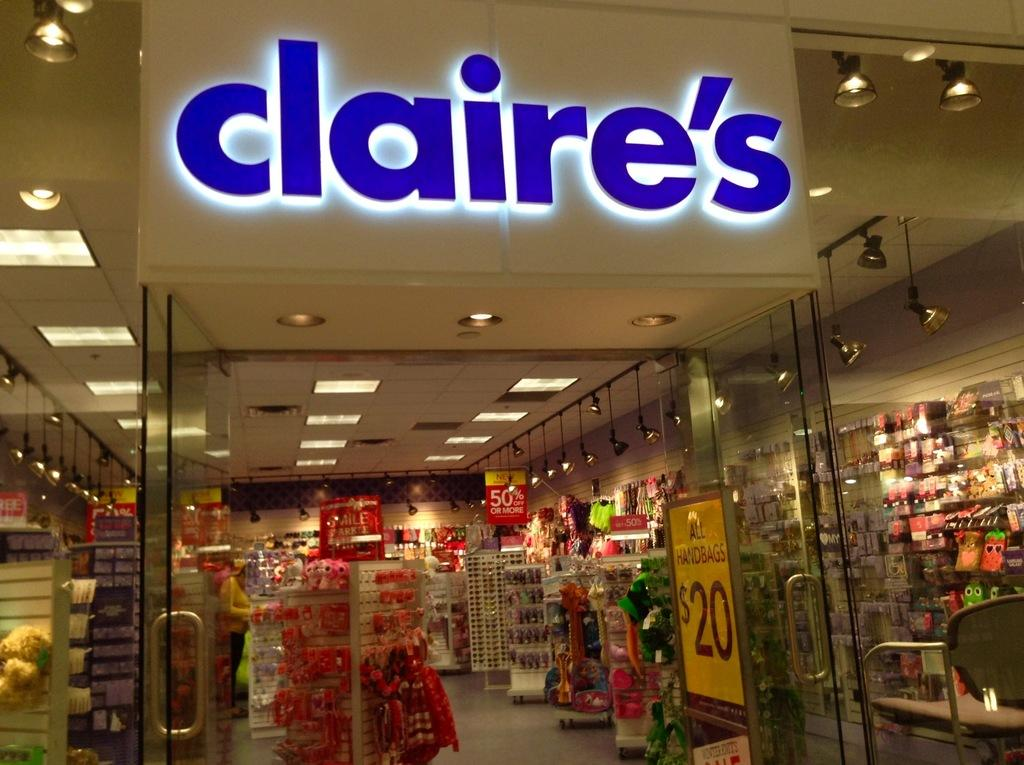<image>
Give a short and clear explanation of the subsequent image. a store called Claire's with many items in it 